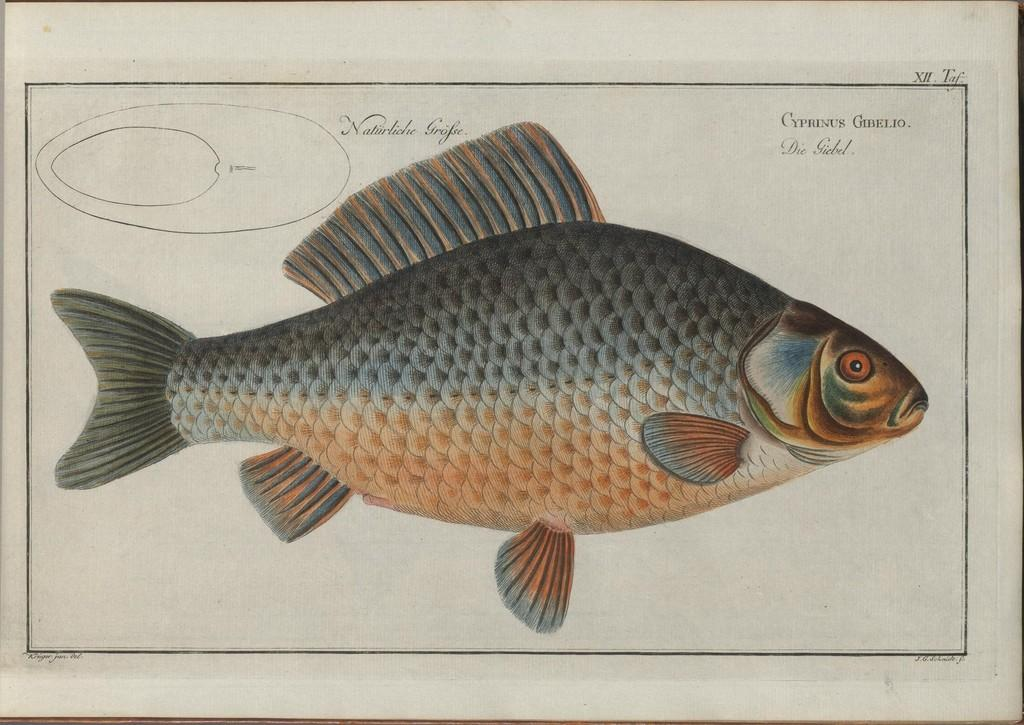What is the main subject of the image? The main subject of the image is a diagram of a fish. What else can be seen on the paper containing the fish diagram? There is writing on the paper containing the fish diagram. How many oranges are hanging from the fish in the image? There are no oranges present in the image; it features a diagram of a fish with writing on the paper. What type of punishment is being given to the fish in the image? There is no punishment being given to the fish in the image; it is a diagram of a fish with writing on the paper. 